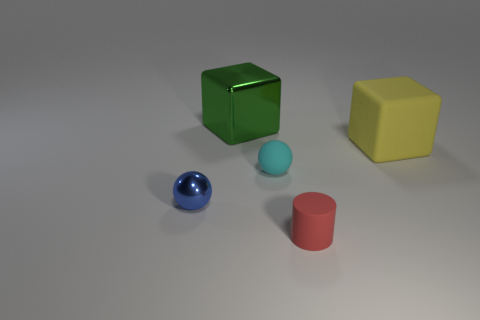Add 2 big shiny things. How many objects exist? 7 Subtract all cylinders. How many objects are left? 4 Add 1 large gray metallic spheres. How many large gray metallic spheres exist? 1 Subtract 0 red blocks. How many objects are left? 5 Subtract all green rubber cylinders. Subtract all yellow objects. How many objects are left? 4 Add 1 shiny spheres. How many shiny spheres are left? 2 